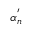<formula> <loc_0><loc_0><loc_500><loc_500>\alpha _ { n } ^ { ^ { \prime } }</formula> 